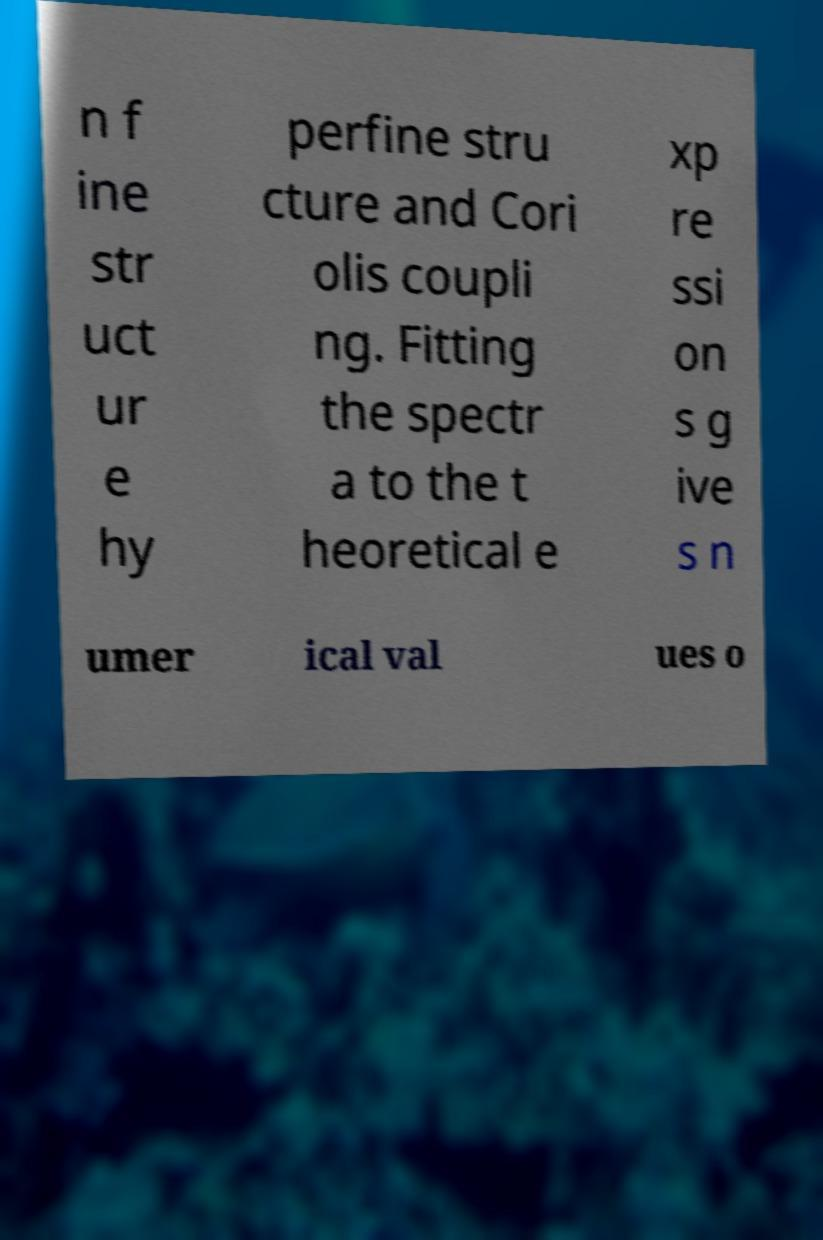Could you extract and type out the text from this image? n f ine str uct ur e hy perfine stru cture and Cori olis coupli ng. Fitting the spectr a to the t heoretical e xp re ssi on s g ive s n umer ical val ues o 